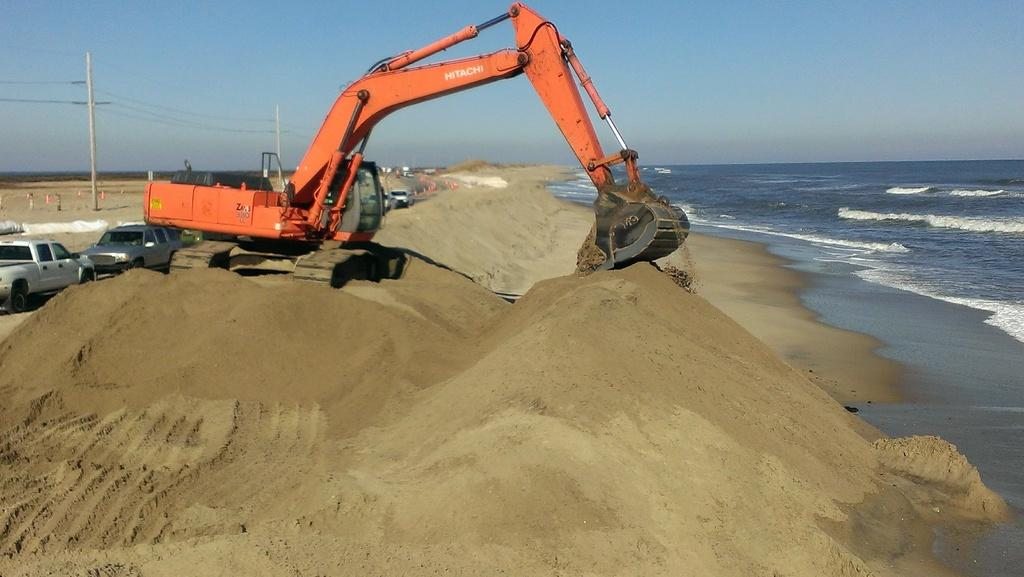What is the main subject in the center of the image? There is a crane and cars in the center of the image. What can be seen on the right side of the image? There is a sea on the right side of the image. What is present at the bottom of the image? There is sand at the bottom of the image. What elements are visible in the background of the image? There are poles, wires, and the sky visible in the background of the image. What health benefits can be gained from the crane in the image? There are no health benefits associated with the crane in the image, as it is a construction vehicle. What rule is being enforced by the presence of the cars in the image? There is no rule being enforced by the presence of the cars in the image; they are simply parked or driving. 